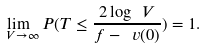Convert formula to latex. <formula><loc_0><loc_0><loc_500><loc_500>\lim _ { \ V \to \infty } P ( T \leq \frac { 2 \log \ V } { f - \ v ( 0 ) } ) = 1 .</formula> 